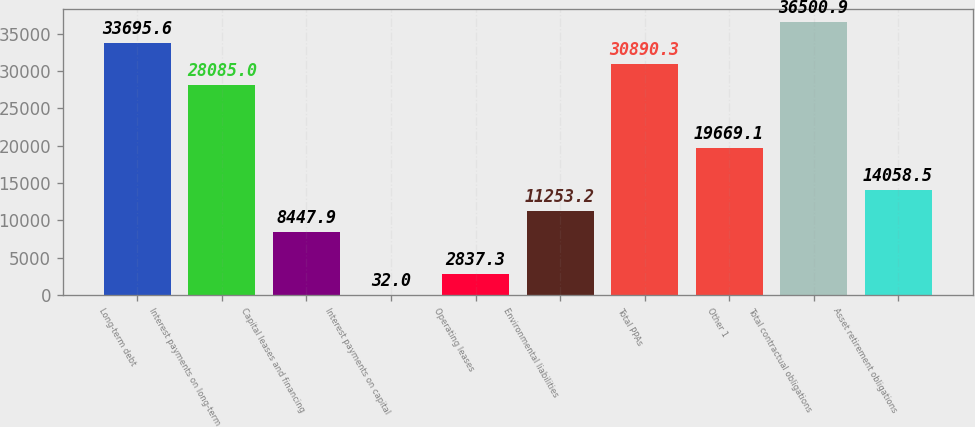<chart> <loc_0><loc_0><loc_500><loc_500><bar_chart><fcel>Long-term debt<fcel>Interest payments on long-term<fcel>Capital leases and financing<fcel>Interest payments on capital<fcel>Operating leases<fcel>Environmental liabilities<fcel>Total PPAs<fcel>Other 1<fcel>Total contractual obligations<fcel>Asset retirement obligations<nl><fcel>33695.6<fcel>28085<fcel>8447.9<fcel>32<fcel>2837.3<fcel>11253.2<fcel>30890.3<fcel>19669.1<fcel>36500.9<fcel>14058.5<nl></chart> 